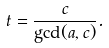<formula> <loc_0><loc_0><loc_500><loc_500>t = \frac { c } { \gcd ( a , c ) } .</formula> 